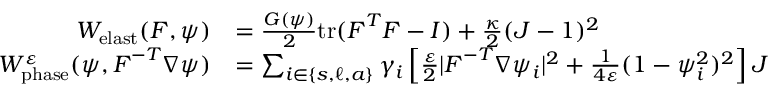<formula> <loc_0><loc_0><loc_500><loc_500>\begin{array} { r l } { W _ { e l a s t } ( F , \psi ) } & { = \frac { G ( \psi ) } { 2 } t r ( F ^ { T } F - I ) + \frac { \kappa } { 2 } ( J - 1 ) ^ { 2 } } \\ { W _ { p h a s e } ^ { \varepsilon } ( \psi , F ^ { - T } \nabla \psi ) } & { = \sum _ { i \in \{ s , \ell , a \} } \gamma _ { i } \left [ \frac { \varepsilon } { 2 } | F ^ { - T } \nabla \psi _ { i } | ^ { 2 } + \frac { 1 } { 4 \varepsilon } ( 1 - \psi _ { i } ^ { 2 } ) ^ { 2 } \right ] J } \end{array}</formula> 